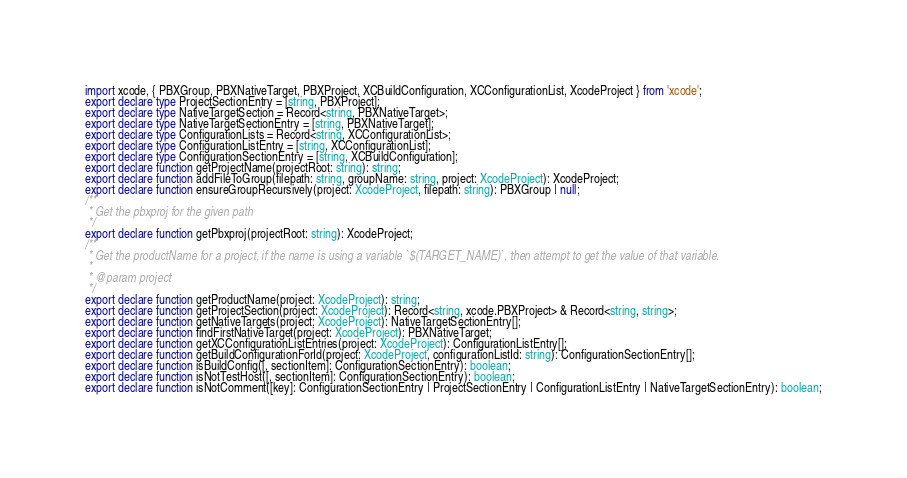<code> <loc_0><loc_0><loc_500><loc_500><_TypeScript_>import xcode, { PBXGroup, PBXNativeTarget, PBXProject, XCBuildConfiguration, XCConfigurationList, XcodeProject } from 'xcode';
export declare type ProjectSectionEntry = [string, PBXProject];
export declare type NativeTargetSection = Record<string, PBXNativeTarget>;
export declare type NativeTargetSectionEntry = [string, PBXNativeTarget];
export declare type ConfigurationLists = Record<string, XCConfigurationList>;
export declare type ConfigurationListEntry = [string, XCConfigurationList];
export declare type ConfigurationSectionEntry = [string, XCBuildConfiguration];
export declare function getProjectName(projectRoot: string): string;
export declare function addFileToGroup(filepath: string, groupName: string, project: XcodeProject): XcodeProject;
export declare function ensureGroupRecursively(project: XcodeProject, filepath: string): PBXGroup | null;
/**
 * Get the pbxproj for the given path
 */
export declare function getPbxproj(projectRoot: string): XcodeProject;
/**
 * Get the productName for a project, if the name is using a variable `$(TARGET_NAME)`, then attempt to get the value of that variable.
 *
 * @param project
 */
export declare function getProductName(project: XcodeProject): string;
export declare function getProjectSection(project: XcodeProject): Record<string, xcode.PBXProject> & Record<string, string>;
export declare function getNativeTargets(project: XcodeProject): NativeTargetSectionEntry[];
export declare function findFirstNativeTarget(project: XcodeProject): PBXNativeTarget;
export declare function getXCConfigurationListEntries(project: XcodeProject): ConfigurationListEntry[];
export declare function getBuildConfigurationForId(project: XcodeProject, configurationListId: string): ConfigurationSectionEntry[];
export declare function isBuildConfig([, sectionItem]: ConfigurationSectionEntry): boolean;
export declare function isNotTestHost([, sectionItem]: ConfigurationSectionEntry): boolean;
export declare function isNotComment([key]: ConfigurationSectionEntry | ProjectSectionEntry | ConfigurationListEntry | NativeTargetSectionEntry): boolean;
</code> 